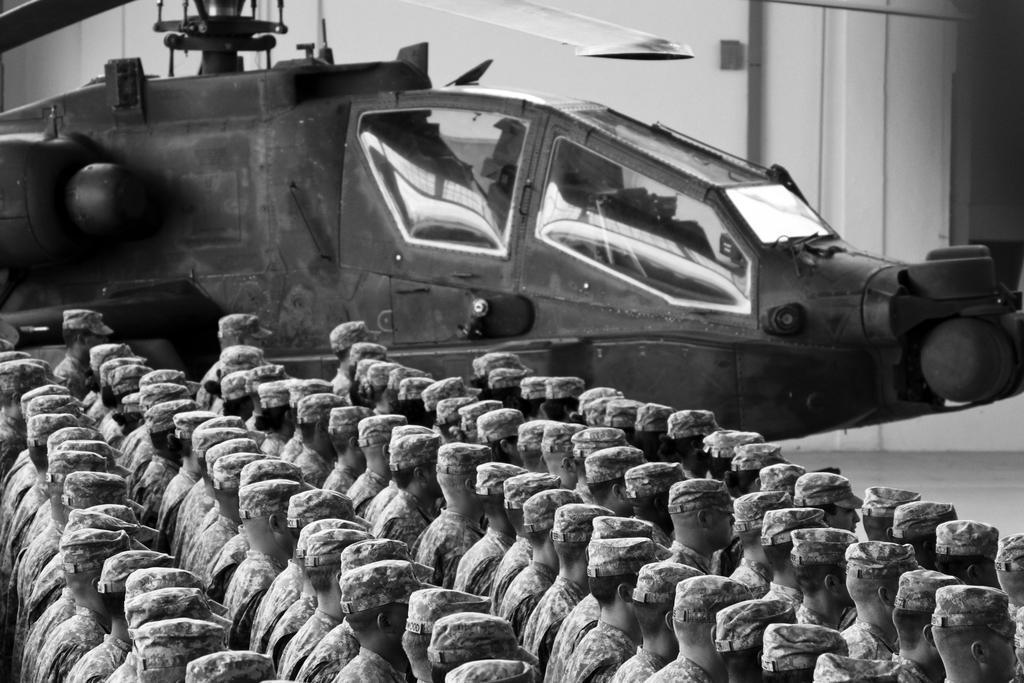Describe this image in one or two sentences. In this image we can see a black and white image. In this image we can see some persons. In the background of the image there is a helicopter and other objects. 